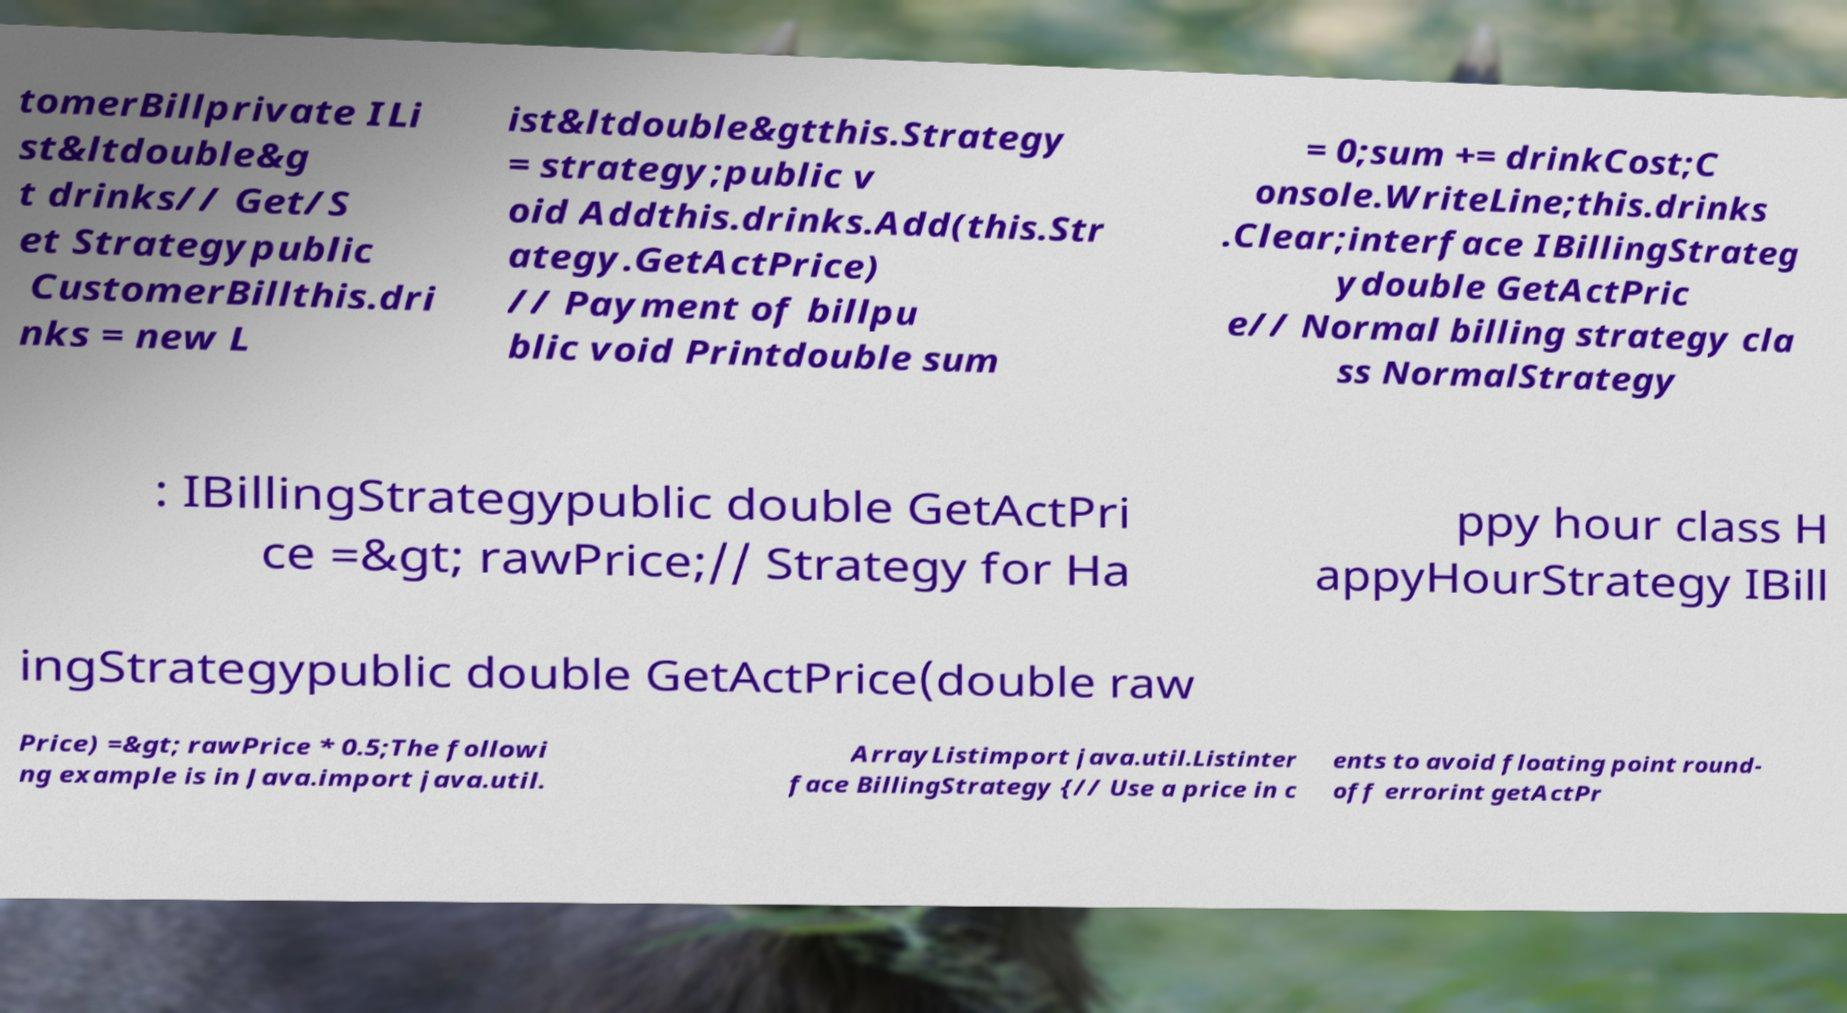Could you extract and type out the text from this image? tomerBillprivate ILi st&ltdouble&g t drinks// Get/S et Strategypublic CustomerBillthis.dri nks = new L ist&ltdouble&gtthis.Strategy = strategy;public v oid Addthis.drinks.Add(this.Str ategy.GetActPrice) // Payment of billpu blic void Printdouble sum = 0;sum += drinkCost;C onsole.WriteLine;this.drinks .Clear;interface IBillingStrateg ydouble GetActPric e// Normal billing strategy cla ss NormalStrategy : IBillingStrategypublic double GetActPri ce =&gt; rawPrice;// Strategy for Ha ppy hour class H appyHourStrategy IBill ingStrategypublic double GetActPrice(double raw Price) =&gt; rawPrice * 0.5;The followi ng example is in Java.import java.util. ArrayListimport java.util.Listinter face BillingStrategy {// Use a price in c ents to avoid floating point round- off errorint getActPr 